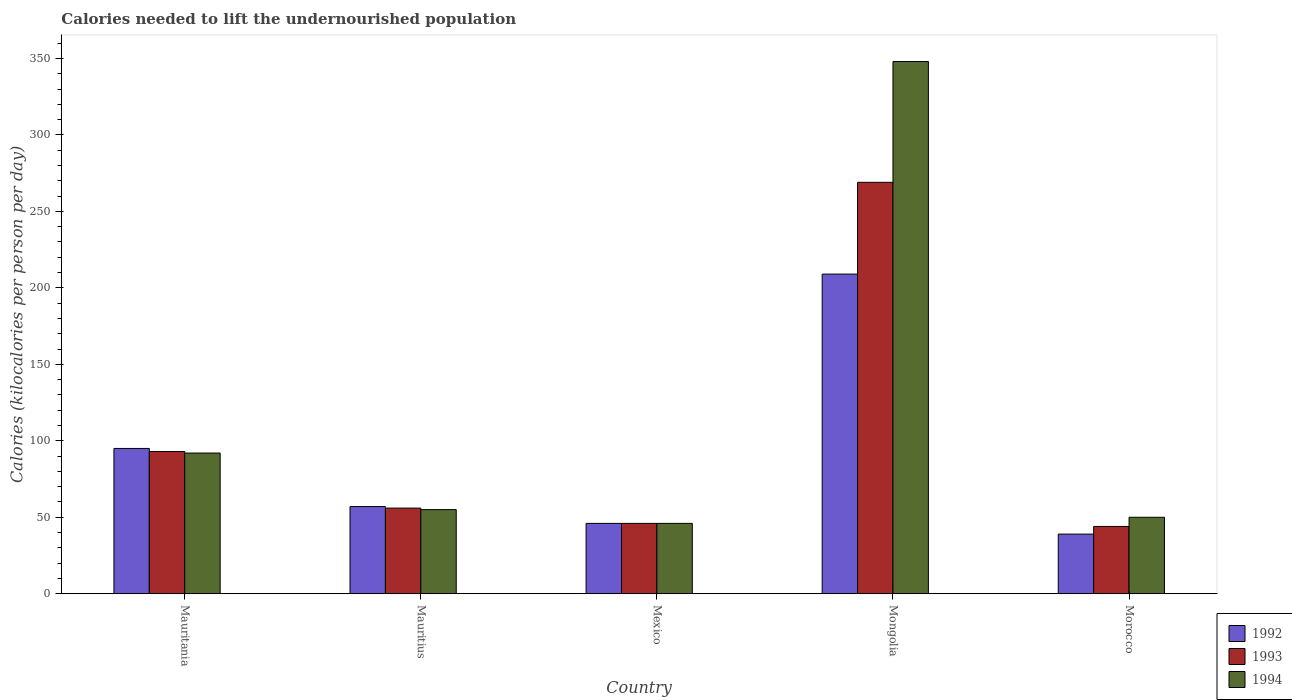Are the number of bars per tick equal to the number of legend labels?
Your answer should be very brief. Yes. How many bars are there on the 2nd tick from the right?
Provide a succinct answer. 3. What is the label of the 3rd group of bars from the left?
Your answer should be compact. Mexico. In how many cases, is the number of bars for a given country not equal to the number of legend labels?
Offer a terse response. 0. What is the total calories needed to lift the undernourished population in 1993 in Morocco?
Keep it short and to the point. 44. Across all countries, what is the maximum total calories needed to lift the undernourished population in 1993?
Make the answer very short. 269. In which country was the total calories needed to lift the undernourished population in 1994 maximum?
Your answer should be very brief. Mongolia. In which country was the total calories needed to lift the undernourished population in 1994 minimum?
Offer a terse response. Mexico. What is the total total calories needed to lift the undernourished population in 1992 in the graph?
Provide a succinct answer. 446. What is the difference between the total calories needed to lift the undernourished population in 1992 in Mauritius and the total calories needed to lift the undernourished population in 1994 in Mauritania?
Your response must be concise. -35. What is the average total calories needed to lift the undernourished population in 1994 per country?
Offer a very short reply. 118.2. What is the ratio of the total calories needed to lift the undernourished population in 1994 in Mauritania to that in Mexico?
Provide a short and direct response. 2. Is the total calories needed to lift the undernourished population in 1994 in Mauritania less than that in Mongolia?
Your answer should be very brief. Yes. What is the difference between the highest and the second highest total calories needed to lift the undernourished population in 1994?
Make the answer very short. 293. What is the difference between the highest and the lowest total calories needed to lift the undernourished population in 1992?
Offer a very short reply. 170. Is it the case that in every country, the sum of the total calories needed to lift the undernourished population in 1994 and total calories needed to lift the undernourished population in 1992 is greater than the total calories needed to lift the undernourished population in 1993?
Make the answer very short. Yes. How many bars are there?
Provide a short and direct response. 15. How many legend labels are there?
Your response must be concise. 3. How are the legend labels stacked?
Keep it short and to the point. Vertical. What is the title of the graph?
Your response must be concise. Calories needed to lift the undernourished population. Does "1986" appear as one of the legend labels in the graph?
Provide a short and direct response. No. What is the label or title of the Y-axis?
Make the answer very short. Calories (kilocalories per person per day). What is the Calories (kilocalories per person per day) of 1993 in Mauritania?
Make the answer very short. 93. What is the Calories (kilocalories per person per day) of 1994 in Mauritania?
Your response must be concise. 92. What is the Calories (kilocalories per person per day) of 1994 in Mauritius?
Keep it short and to the point. 55. What is the Calories (kilocalories per person per day) in 1992 in Mexico?
Give a very brief answer. 46. What is the Calories (kilocalories per person per day) in 1993 in Mexico?
Offer a very short reply. 46. What is the Calories (kilocalories per person per day) in 1992 in Mongolia?
Offer a terse response. 209. What is the Calories (kilocalories per person per day) in 1993 in Mongolia?
Give a very brief answer. 269. What is the Calories (kilocalories per person per day) in 1994 in Mongolia?
Your response must be concise. 348. What is the Calories (kilocalories per person per day) of 1993 in Morocco?
Your answer should be compact. 44. What is the Calories (kilocalories per person per day) of 1994 in Morocco?
Provide a succinct answer. 50. Across all countries, what is the maximum Calories (kilocalories per person per day) in 1992?
Your response must be concise. 209. Across all countries, what is the maximum Calories (kilocalories per person per day) of 1993?
Provide a short and direct response. 269. Across all countries, what is the maximum Calories (kilocalories per person per day) in 1994?
Give a very brief answer. 348. Across all countries, what is the minimum Calories (kilocalories per person per day) of 1994?
Provide a short and direct response. 46. What is the total Calories (kilocalories per person per day) of 1992 in the graph?
Offer a very short reply. 446. What is the total Calories (kilocalories per person per day) of 1993 in the graph?
Ensure brevity in your answer.  508. What is the total Calories (kilocalories per person per day) of 1994 in the graph?
Provide a short and direct response. 591. What is the difference between the Calories (kilocalories per person per day) in 1994 in Mauritania and that in Mauritius?
Offer a very short reply. 37. What is the difference between the Calories (kilocalories per person per day) in 1993 in Mauritania and that in Mexico?
Ensure brevity in your answer.  47. What is the difference between the Calories (kilocalories per person per day) of 1994 in Mauritania and that in Mexico?
Your response must be concise. 46. What is the difference between the Calories (kilocalories per person per day) of 1992 in Mauritania and that in Mongolia?
Ensure brevity in your answer.  -114. What is the difference between the Calories (kilocalories per person per day) of 1993 in Mauritania and that in Mongolia?
Your answer should be compact. -176. What is the difference between the Calories (kilocalories per person per day) of 1994 in Mauritania and that in Mongolia?
Provide a short and direct response. -256. What is the difference between the Calories (kilocalories per person per day) of 1992 in Mauritania and that in Morocco?
Keep it short and to the point. 56. What is the difference between the Calories (kilocalories per person per day) of 1993 in Mauritania and that in Morocco?
Offer a terse response. 49. What is the difference between the Calories (kilocalories per person per day) in 1994 in Mauritania and that in Morocco?
Your answer should be very brief. 42. What is the difference between the Calories (kilocalories per person per day) in 1992 in Mauritius and that in Mexico?
Your response must be concise. 11. What is the difference between the Calories (kilocalories per person per day) of 1993 in Mauritius and that in Mexico?
Give a very brief answer. 10. What is the difference between the Calories (kilocalories per person per day) in 1992 in Mauritius and that in Mongolia?
Provide a short and direct response. -152. What is the difference between the Calories (kilocalories per person per day) in 1993 in Mauritius and that in Mongolia?
Keep it short and to the point. -213. What is the difference between the Calories (kilocalories per person per day) in 1994 in Mauritius and that in Mongolia?
Your answer should be very brief. -293. What is the difference between the Calories (kilocalories per person per day) in 1994 in Mauritius and that in Morocco?
Keep it short and to the point. 5. What is the difference between the Calories (kilocalories per person per day) of 1992 in Mexico and that in Mongolia?
Your answer should be very brief. -163. What is the difference between the Calories (kilocalories per person per day) in 1993 in Mexico and that in Mongolia?
Keep it short and to the point. -223. What is the difference between the Calories (kilocalories per person per day) in 1994 in Mexico and that in Mongolia?
Offer a terse response. -302. What is the difference between the Calories (kilocalories per person per day) of 1994 in Mexico and that in Morocco?
Keep it short and to the point. -4. What is the difference between the Calories (kilocalories per person per day) in 1992 in Mongolia and that in Morocco?
Keep it short and to the point. 170. What is the difference between the Calories (kilocalories per person per day) in 1993 in Mongolia and that in Morocco?
Keep it short and to the point. 225. What is the difference between the Calories (kilocalories per person per day) of 1994 in Mongolia and that in Morocco?
Offer a very short reply. 298. What is the difference between the Calories (kilocalories per person per day) in 1992 in Mauritania and the Calories (kilocalories per person per day) in 1993 in Mauritius?
Your answer should be compact. 39. What is the difference between the Calories (kilocalories per person per day) in 1992 in Mauritania and the Calories (kilocalories per person per day) in 1993 in Mexico?
Give a very brief answer. 49. What is the difference between the Calories (kilocalories per person per day) in 1992 in Mauritania and the Calories (kilocalories per person per day) in 1994 in Mexico?
Give a very brief answer. 49. What is the difference between the Calories (kilocalories per person per day) of 1993 in Mauritania and the Calories (kilocalories per person per day) of 1994 in Mexico?
Your answer should be very brief. 47. What is the difference between the Calories (kilocalories per person per day) in 1992 in Mauritania and the Calories (kilocalories per person per day) in 1993 in Mongolia?
Keep it short and to the point. -174. What is the difference between the Calories (kilocalories per person per day) in 1992 in Mauritania and the Calories (kilocalories per person per day) in 1994 in Mongolia?
Provide a short and direct response. -253. What is the difference between the Calories (kilocalories per person per day) in 1993 in Mauritania and the Calories (kilocalories per person per day) in 1994 in Mongolia?
Your response must be concise. -255. What is the difference between the Calories (kilocalories per person per day) in 1992 in Mauritania and the Calories (kilocalories per person per day) in 1993 in Morocco?
Provide a succinct answer. 51. What is the difference between the Calories (kilocalories per person per day) in 1992 in Mauritania and the Calories (kilocalories per person per day) in 1994 in Morocco?
Make the answer very short. 45. What is the difference between the Calories (kilocalories per person per day) of 1993 in Mauritania and the Calories (kilocalories per person per day) of 1994 in Morocco?
Give a very brief answer. 43. What is the difference between the Calories (kilocalories per person per day) in 1992 in Mauritius and the Calories (kilocalories per person per day) in 1993 in Mexico?
Provide a succinct answer. 11. What is the difference between the Calories (kilocalories per person per day) of 1992 in Mauritius and the Calories (kilocalories per person per day) of 1994 in Mexico?
Offer a terse response. 11. What is the difference between the Calories (kilocalories per person per day) of 1993 in Mauritius and the Calories (kilocalories per person per day) of 1994 in Mexico?
Provide a short and direct response. 10. What is the difference between the Calories (kilocalories per person per day) of 1992 in Mauritius and the Calories (kilocalories per person per day) of 1993 in Mongolia?
Keep it short and to the point. -212. What is the difference between the Calories (kilocalories per person per day) in 1992 in Mauritius and the Calories (kilocalories per person per day) in 1994 in Mongolia?
Give a very brief answer. -291. What is the difference between the Calories (kilocalories per person per day) in 1993 in Mauritius and the Calories (kilocalories per person per day) in 1994 in Mongolia?
Provide a short and direct response. -292. What is the difference between the Calories (kilocalories per person per day) of 1992 in Mauritius and the Calories (kilocalories per person per day) of 1993 in Morocco?
Give a very brief answer. 13. What is the difference between the Calories (kilocalories per person per day) in 1992 in Mexico and the Calories (kilocalories per person per day) in 1993 in Mongolia?
Give a very brief answer. -223. What is the difference between the Calories (kilocalories per person per day) in 1992 in Mexico and the Calories (kilocalories per person per day) in 1994 in Mongolia?
Provide a short and direct response. -302. What is the difference between the Calories (kilocalories per person per day) in 1993 in Mexico and the Calories (kilocalories per person per day) in 1994 in Mongolia?
Make the answer very short. -302. What is the difference between the Calories (kilocalories per person per day) in 1992 in Mexico and the Calories (kilocalories per person per day) in 1993 in Morocco?
Ensure brevity in your answer.  2. What is the difference between the Calories (kilocalories per person per day) of 1993 in Mexico and the Calories (kilocalories per person per day) of 1994 in Morocco?
Provide a succinct answer. -4. What is the difference between the Calories (kilocalories per person per day) of 1992 in Mongolia and the Calories (kilocalories per person per day) of 1993 in Morocco?
Make the answer very short. 165. What is the difference between the Calories (kilocalories per person per day) in 1992 in Mongolia and the Calories (kilocalories per person per day) in 1994 in Morocco?
Give a very brief answer. 159. What is the difference between the Calories (kilocalories per person per day) of 1993 in Mongolia and the Calories (kilocalories per person per day) of 1994 in Morocco?
Your response must be concise. 219. What is the average Calories (kilocalories per person per day) in 1992 per country?
Give a very brief answer. 89.2. What is the average Calories (kilocalories per person per day) of 1993 per country?
Your response must be concise. 101.6. What is the average Calories (kilocalories per person per day) of 1994 per country?
Offer a very short reply. 118.2. What is the difference between the Calories (kilocalories per person per day) in 1992 and Calories (kilocalories per person per day) in 1993 in Mauritania?
Your answer should be very brief. 2. What is the difference between the Calories (kilocalories per person per day) in 1992 and Calories (kilocalories per person per day) in 1994 in Mauritania?
Offer a very short reply. 3. What is the difference between the Calories (kilocalories per person per day) in 1993 and Calories (kilocalories per person per day) in 1994 in Mauritania?
Give a very brief answer. 1. What is the difference between the Calories (kilocalories per person per day) of 1992 and Calories (kilocalories per person per day) of 1993 in Mauritius?
Provide a succinct answer. 1. What is the difference between the Calories (kilocalories per person per day) in 1993 and Calories (kilocalories per person per day) in 1994 in Mauritius?
Your answer should be very brief. 1. What is the difference between the Calories (kilocalories per person per day) in 1992 and Calories (kilocalories per person per day) in 1993 in Mexico?
Offer a very short reply. 0. What is the difference between the Calories (kilocalories per person per day) in 1993 and Calories (kilocalories per person per day) in 1994 in Mexico?
Provide a succinct answer. 0. What is the difference between the Calories (kilocalories per person per day) in 1992 and Calories (kilocalories per person per day) in 1993 in Mongolia?
Offer a very short reply. -60. What is the difference between the Calories (kilocalories per person per day) of 1992 and Calories (kilocalories per person per day) of 1994 in Mongolia?
Keep it short and to the point. -139. What is the difference between the Calories (kilocalories per person per day) in 1993 and Calories (kilocalories per person per day) in 1994 in Mongolia?
Ensure brevity in your answer.  -79. What is the difference between the Calories (kilocalories per person per day) in 1992 and Calories (kilocalories per person per day) in 1993 in Morocco?
Ensure brevity in your answer.  -5. What is the ratio of the Calories (kilocalories per person per day) of 1993 in Mauritania to that in Mauritius?
Your response must be concise. 1.66. What is the ratio of the Calories (kilocalories per person per day) in 1994 in Mauritania to that in Mauritius?
Ensure brevity in your answer.  1.67. What is the ratio of the Calories (kilocalories per person per day) of 1992 in Mauritania to that in Mexico?
Offer a very short reply. 2.07. What is the ratio of the Calories (kilocalories per person per day) of 1993 in Mauritania to that in Mexico?
Provide a succinct answer. 2.02. What is the ratio of the Calories (kilocalories per person per day) in 1992 in Mauritania to that in Mongolia?
Provide a succinct answer. 0.45. What is the ratio of the Calories (kilocalories per person per day) of 1993 in Mauritania to that in Mongolia?
Give a very brief answer. 0.35. What is the ratio of the Calories (kilocalories per person per day) in 1994 in Mauritania to that in Mongolia?
Your answer should be very brief. 0.26. What is the ratio of the Calories (kilocalories per person per day) in 1992 in Mauritania to that in Morocco?
Your answer should be very brief. 2.44. What is the ratio of the Calories (kilocalories per person per day) in 1993 in Mauritania to that in Morocco?
Keep it short and to the point. 2.11. What is the ratio of the Calories (kilocalories per person per day) in 1994 in Mauritania to that in Morocco?
Offer a very short reply. 1.84. What is the ratio of the Calories (kilocalories per person per day) of 1992 in Mauritius to that in Mexico?
Offer a terse response. 1.24. What is the ratio of the Calories (kilocalories per person per day) of 1993 in Mauritius to that in Mexico?
Give a very brief answer. 1.22. What is the ratio of the Calories (kilocalories per person per day) of 1994 in Mauritius to that in Mexico?
Offer a very short reply. 1.2. What is the ratio of the Calories (kilocalories per person per day) in 1992 in Mauritius to that in Mongolia?
Offer a terse response. 0.27. What is the ratio of the Calories (kilocalories per person per day) in 1993 in Mauritius to that in Mongolia?
Provide a succinct answer. 0.21. What is the ratio of the Calories (kilocalories per person per day) in 1994 in Mauritius to that in Mongolia?
Ensure brevity in your answer.  0.16. What is the ratio of the Calories (kilocalories per person per day) in 1992 in Mauritius to that in Morocco?
Give a very brief answer. 1.46. What is the ratio of the Calories (kilocalories per person per day) in 1993 in Mauritius to that in Morocco?
Keep it short and to the point. 1.27. What is the ratio of the Calories (kilocalories per person per day) of 1994 in Mauritius to that in Morocco?
Your answer should be very brief. 1.1. What is the ratio of the Calories (kilocalories per person per day) of 1992 in Mexico to that in Mongolia?
Offer a very short reply. 0.22. What is the ratio of the Calories (kilocalories per person per day) in 1993 in Mexico to that in Mongolia?
Your answer should be compact. 0.17. What is the ratio of the Calories (kilocalories per person per day) in 1994 in Mexico to that in Mongolia?
Provide a succinct answer. 0.13. What is the ratio of the Calories (kilocalories per person per day) of 1992 in Mexico to that in Morocco?
Offer a very short reply. 1.18. What is the ratio of the Calories (kilocalories per person per day) in 1993 in Mexico to that in Morocco?
Provide a succinct answer. 1.05. What is the ratio of the Calories (kilocalories per person per day) of 1994 in Mexico to that in Morocco?
Make the answer very short. 0.92. What is the ratio of the Calories (kilocalories per person per day) in 1992 in Mongolia to that in Morocco?
Give a very brief answer. 5.36. What is the ratio of the Calories (kilocalories per person per day) in 1993 in Mongolia to that in Morocco?
Offer a terse response. 6.11. What is the ratio of the Calories (kilocalories per person per day) of 1994 in Mongolia to that in Morocco?
Make the answer very short. 6.96. What is the difference between the highest and the second highest Calories (kilocalories per person per day) in 1992?
Your answer should be compact. 114. What is the difference between the highest and the second highest Calories (kilocalories per person per day) in 1993?
Your answer should be compact. 176. What is the difference between the highest and the second highest Calories (kilocalories per person per day) of 1994?
Your answer should be very brief. 256. What is the difference between the highest and the lowest Calories (kilocalories per person per day) in 1992?
Offer a very short reply. 170. What is the difference between the highest and the lowest Calories (kilocalories per person per day) of 1993?
Provide a succinct answer. 225. What is the difference between the highest and the lowest Calories (kilocalories per person per day) of 1994?
Provide a short and direct response. 302. 